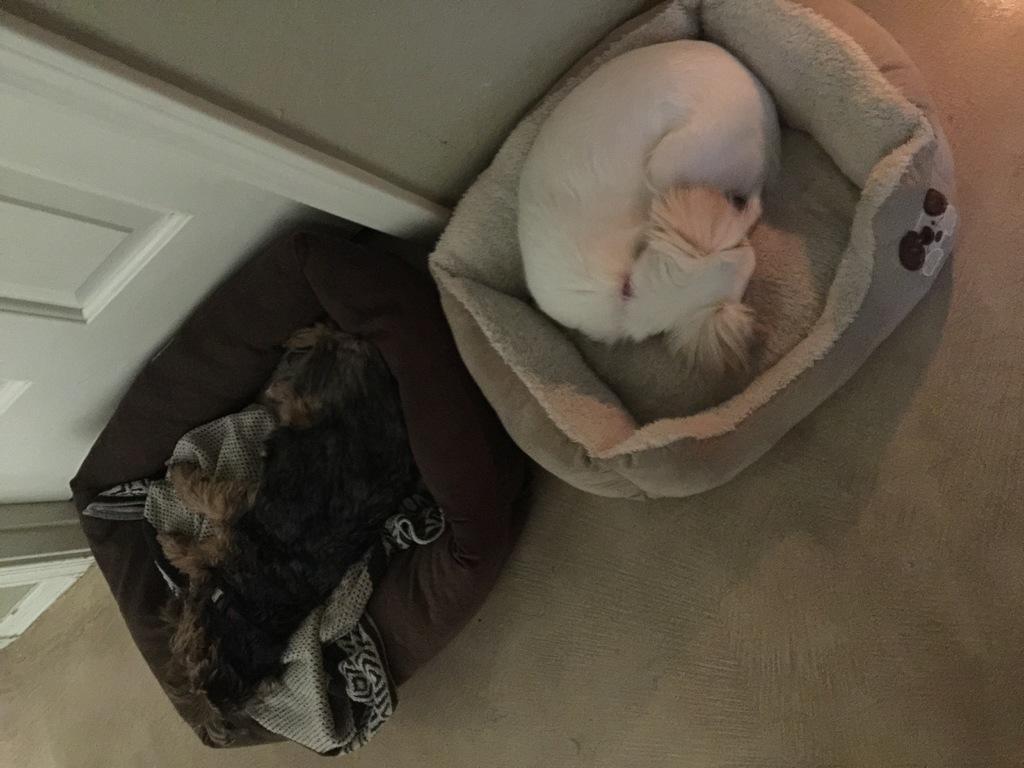Describe this image in one or two sentences. In this image we can see the dogs lying on the dog beds which are on the floor. In the background we can see the wall and also the door. 